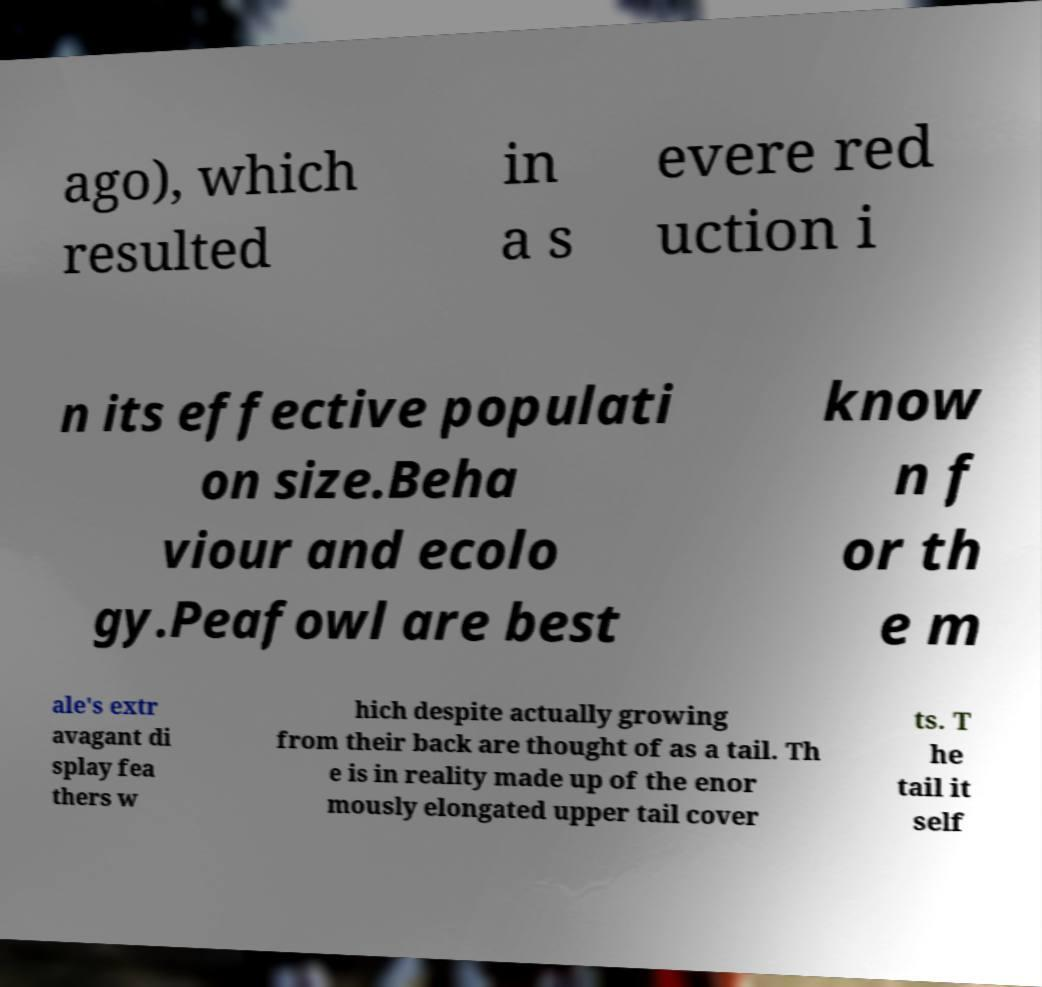I need the written content from this picture converted into text. Can you do that? ago), which resulted in a s evere red uction i n its effective populati on size.Beha viour and ecolo gy.Peafowl are best know n f or th e m ale's extr avagant di splay fea thers w hich despite actually growing from their back are thought of as a tail. Th e is in reality made up of the enor mously elongated upper tail cover ts. T he tail it self 